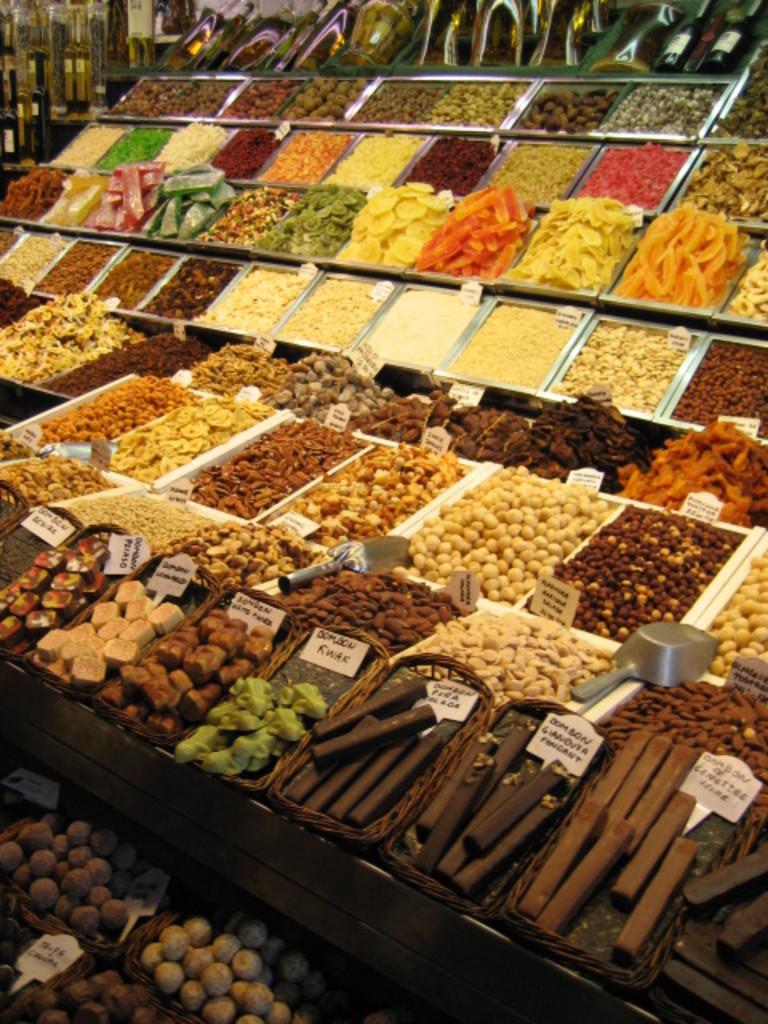What type of food items can be seen in the image? There are many snacks in the image, including nuts. Are there any other food-related items visible in the image? Yes, there are other cooking items in the image. How are the items arranged in the image? The items are divided into parts and kept in a display. What type of joke can be seen in the image? There is no joke present in the image; it features snacks, nuts, and other cooking items arranged in a display. 